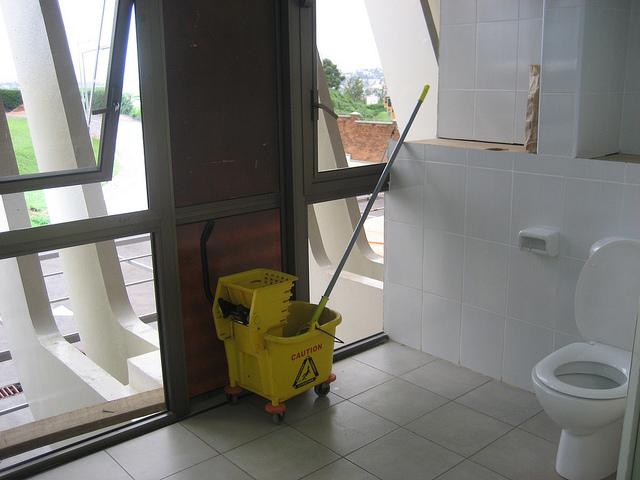What did housekeeping forget?
Answer briefly. Mop bucket. Is this bathroom clean?
Give a very brief answer. Yes. What color bucket is in the room?
Give a very brief answer. Yellow. 